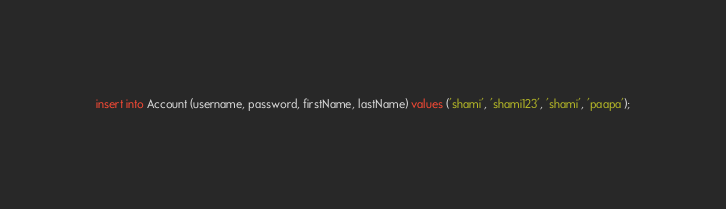Convert code to text. <code><loc_0><loc_0><loc_500><loc_500><_SQL_>insert into Account (username, password, firstName, lastName) values ('shami', 'shami123', 'shami', 'paapa');

</code> 